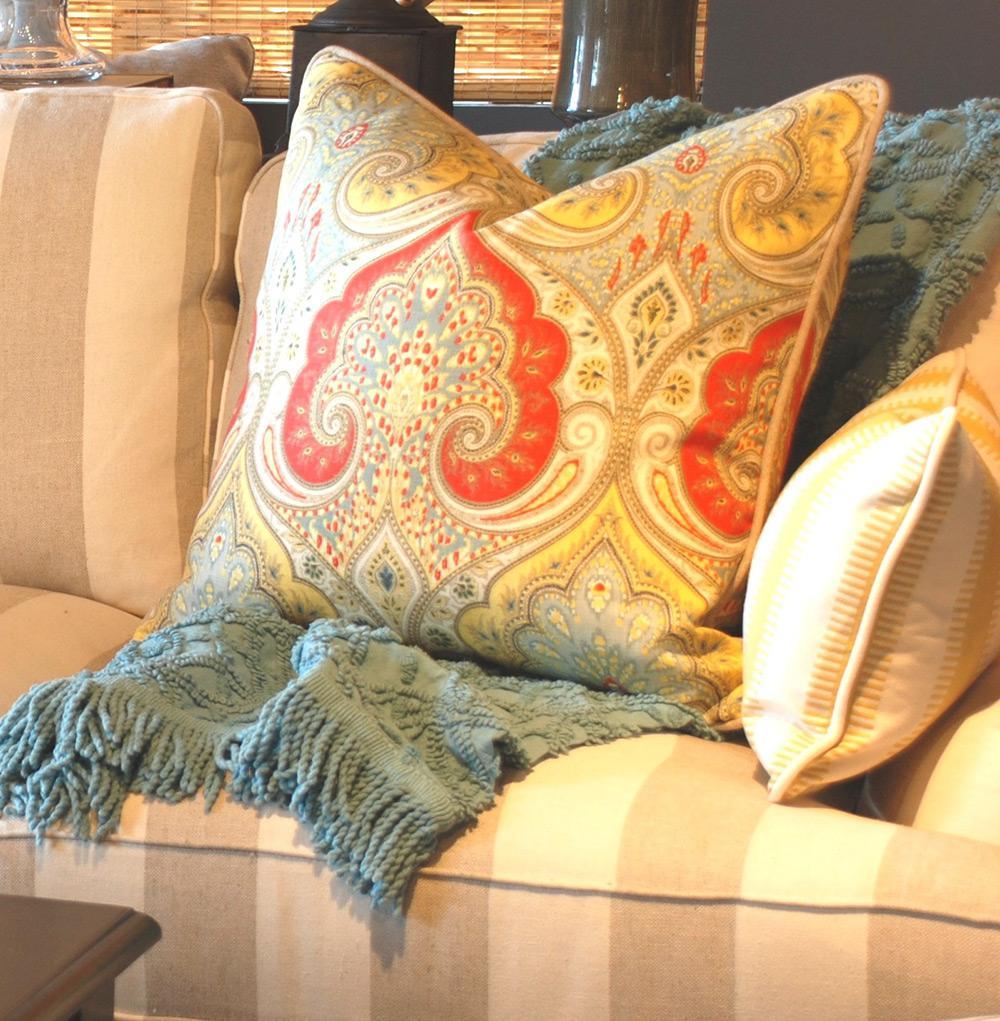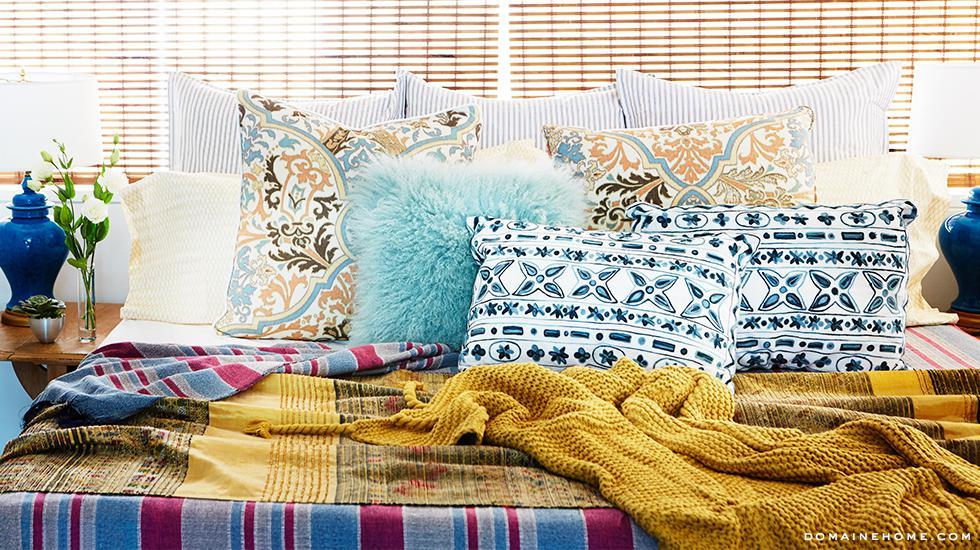The first image is the image on the left, the second image is the image on the right. Assess this claim about the two images: "There is at least two pillows in the right image.". Correct or not? Answer yes or no. Yes. The first image is the image on the left, the second image is the image on the right. For the images displayed, is the sentence "There are flowers on at least one pillow in each image, and none of the pillow are fuzzy." factually correct? Answer yes or no. No. 